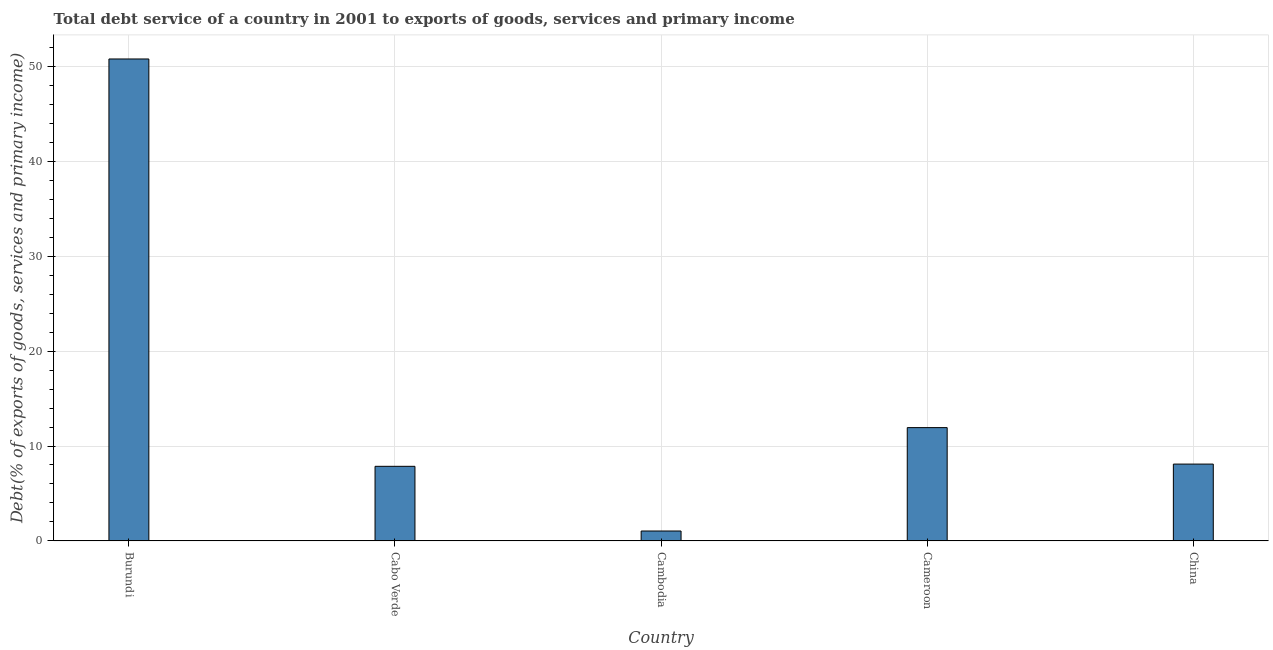Does the graph contain grids?
Provide a short and direct response. Yes. What is the title of the graph?
Your response must be concise. Total debt service of a country in 2001 to exports of goods, services and primary income. What is the label or title of the X-axis?
Your response must be concise. Country. What is the label or title of the Y-axis?
Ensure brevity in your answer.  Debt(% of exports of goods, services and primary income). What is the total debt service in Cambodia?
Offer a terse response. 1.04. Across all countries, what is the maximum total debt service?
Your answer should be very brief. 50.78. Across all countries, what is the minimum total debt service?
Your response must be concise. 1.04. In which country was the total debt service maximum?
Give a very brief answer. Burundi. In which country was the total debt service minimum?
Keep it short and to the point. Cambodia. What is the sum of the total debt service?
Provide a short and direct response. 79.71. What is the difference between the total debt service in Burundi and Cameroon?
Offer a terse response. 38.84. What is the average total debt service per country?
Make the answer very short. 15.94. What is the median total debt service?
Make the answer very short. 8.09. What is the ratio of the total debt service in Burundi to that in Cameroon?
Provide a short and direct response. 4.25. What is the difference between the highest and the second highest total debt service?
Ensure brevity in your answer.  38.84. Is the sum of the total debt service in Burundi and Cambodia greater than the maximum total debt service across all countries?
Offer a very short reply. Yes. What is the difference between the highest and the lowest total debt service?
Your answer should be very brief. 49.73. How many bars are there?
Provide a short and direct response. 5. How many countries are there in the graph?
Offer a terse response. 5. What is the difference between two consecutive major ticks on the Y-axis?
Your answer should be very brief. 10. What is the Debt(% of exports of goods, services and primary income) in Burundi?
Give a very brief answer. 50.78. What is the Debt(% of exports of goods, services and primary income) in Cabo Verde?
Keep it short and to the point. 7.86. What is the Debt(% of exports of goods, services and primary income) of Cambodia?
Your answer should be very brief. 1.04. What is the Debt(% of exports of goods, services and primary income) in Cameroon?
Ensure brevity in your answer.  11.94. What is the Debt(% of exports of goods, services and primary income) of China?
Give a very brief answer. 8.09. What is the difference between the Debt(% of exports of goods, services and primary income) in Burundi and Cabo Verde?
Your answer should be compact. 42.92. What is the difference between the Debt(% of exports of goods, services and primary income) in Burundi and Cambodia?
Make the answer very short. 49.73. What is the difference between the Debt(% of exports of goods, services and primary income) in Burundi and Cameroon?
Provide a succinct answer. 38.84. What is the difference between the Debt(% of exports of goods, services and primary income) in Burundi and China?
Your answer should be compact. 42.68. What is the difference between the Debt(% of exports of goods, services and primary income) in Cabo Verde and Cambodia?
Provide a succinct answer. 6.82. What is the difference between the Debt(% of exports of goods, services and primary income) in Cabo Verde and Cameroon?
Provide a short and direct response. -4.08. What is the difference between the Debt(% of exports of goods, services and primary income) in Cabo Verde and China?
Your answer should be very brief. -0.23. What is the difference between the Debt(% of exports of goods, services and primary income) in Cambodia and Cameroon?
Your answer should be compact. -10.89. What is the difference between the Debt(% of exports of goods, services and primary income) in Cambodia and China?
Provide a short and direct response. -7.05. What is the difference between the Debt(% of exports of goods, services and primary income) in Cameroon and China?
Your answer should be compact. 3.84. What is the ratio of the Debt(% of exports of goods, services and primary income) in Burundi to that in Cabo Verde?
Your answer should be compact. 6.46. What is the ratio of the Debt(% of exports of goods, services and primary income) in Burundi to that in Cambodia?
Your answer should be very brief. 48.61. What is the ratio of the Debt(% of exports of goods, services and primary income) in Burundi to that in Cameroon?
Provide a short and direct response. 4.25. What is the ratio of the Debt(% of exports of goods, services and primary income) in Burundi to that in China?
Make the answer very short. 6.27. What is the ratio of the Debt(% of exports of goods, services and primary income) in Cabo Verde to that in Cambodia?
Provide a succinct answer. 7.52. What is the ratio of the Debt(% of exports of goods, services and primary income) in Cabo Verde to that in Cameroon?
Offer a terse response. 0.66. What is the ratio of the Debt(% of exports of goods, services and primary income) in Cabo Verde to that in China?
Your response must be concise. 0.97. What is the ratio of the Debt(% of exports of goods, services and primary income) in Cambodia to that in Cameroon?
Your response must be concise. 0.09. What is the ratio of the Debt(% of exports of goods, services and primary income) in Cambodia to that in China?
Give a very brief answer. 0.13. What is the ratio of the Debt(% of exports of goods, services and primary income) in Cameroon to that in China?
Keep it short and to the point. 1.48. 